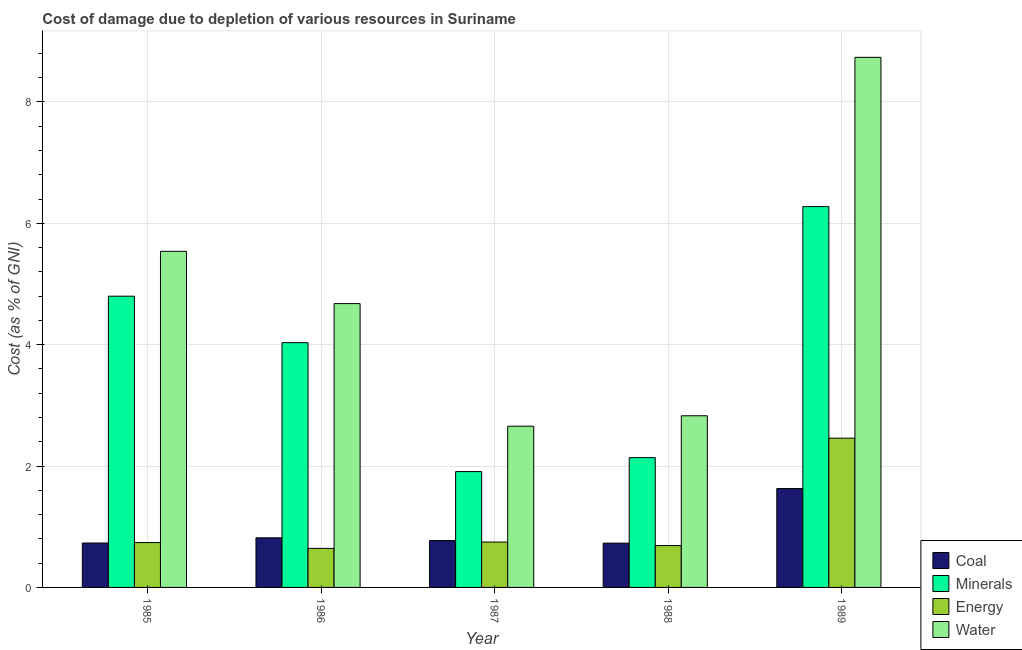How many different coloured bars are there?
Give a very brief answer. 4. What is the cost of damage due to depletion of coal in 1987?
Your response must be concise. 0.77. Across all years, what is the maximum cost of damage due to depletion of minerals?
Give a very brief answer. 6.28. Across all years, what is the minimum cost of damage due to depletion of water?
Provide a short and direct response. 2.66. In which year was the cost of damage due to depletion of water minimum?
Provide a short and direct response. 1987. What is the total cost of damage due to depletion of coal in the graph?
Provide a succinct answer. 4.68. What is the difference between the cost of damage due to depletion of minerals in 1985 and that in 1986?
Offer a terse response. 0.77. What is the difference between the cost of damage due to depletion of water in 1986 and the cost of damage due to depletion of coal in 1987?
Your answer should be compact. 2.02. What is the average cost of damage due to depletion of coal per year?
Your response must be concise. 0.94. In the year 1989, what is the difference between the cost of damage due to depletion of minerals and cost of damage due to depletion of energy?
Offer a very short reply. 0. In how many years, is the cost of damage due to depletion of water greater than 1.2000000000000002 %?
Make the answer very short. 5. What is the ratio of the cost of damage due to depletion of water in 1985 to that in 1989?
Your answer should be compact. 0.63. What is the difference between the highest and the second highest cost of damage due to depletion of water?
Keep it short and to the point. 3.2. What is the difference between the highest and the lowest cost of damage due to depletion of water?
Make the answer very short. 6.08. Is it the case that in every year, the sum of the cost of damage due to depletion of water and cost of damage due to depletion of minerals is greater than the sum of cost of damage due to depletion of coal and cost of damage due to depletion of energy?
Provide a short and direct response. Yes. What does the 2nd bar from the left in 1988 represents?
Provide a short and direct response. Minerals. What does the 1st bar from the right in 1989 represents?
Provide a succinct answer. Water. Is it the case that in every year, the sum of the cost of damage due to depletion of coal and cost of damage due to depletion of minerals is greater than the cost of damage due to depletion of energy?
Provide a succinct answer. Yes. How many bars are there?
Provide a short and direct response. 20. How many years are there in the graph?
Give a very brief answer. 5. What is the difference between two consecutive major ticks on the Y-axis?
Provide a short and direct response. 2. Are the values on the major ticks of Y-axis written in scientific E-notation?
Give a very brief answer. No. Where does the legend appear in the graph?
Provide a succinct answer. Bottom right. What is the title of the graph?
Make the answer very short. Cost of damage due to depletion of various resources in Suriname . What is the label or title of the Y-axis?
Ensure brevity in your answer.  Cost (as % of GNI). What is the Cost (as % of GNI) of Coal in 1985?
Provide a short and direct response. 0.73. What is the Cost (as % of GNI) in Minerals in 1985?
Your response must be concise. 4.8. What is the Cost (as % of GNI) of Energy in 1985?
Give a very brief answer. 0.74. What is the Cost (as % of GNI) of Water in 1985?
Ensure brevity in your answer.  5.54. What is the Cost (as % of GNI) of Coal in 1986?
Your response must be concise. 0.82. What is the Cost (as % of GNI) in Minerals in 1986?
Your response must be concise. 4.03. What is the Cost (as % of GNI) of Energy in 1986?
Your response must be concise. 0.64. What is the Cost (as % of GNI) of Water in 1986?
Provide a short and direct response. 4.68. What is the Cost (as % of GNI) in Coal in 1987?
Your response must be concise. 0.77. What is the Cost (as % of GNI) in Minerals in 1987?
Ensure brevity in your answer.  1.91. What is the Cost (as % of GNI) in Energy in 1987?
Your answer should be compact. 0.75. What is the Cost (as % of GNI) in Water in 1987?
Give a very brief answer. 2.66. What is the Cost (as % of GNI) of Coal in 1988?
Provide a short and direct response. 0.73. What is the Cost (as % of GNI) in Minerals in 1988?
Provide a short and direct response. 2.14. What is the Cost (as % of GNI) in Energy in 1988?
Give a very brief answer. 0.69. What is the Cost (as % of GNI) of Water in 1988?
Provide a succinct answer. 2.83. What is the Cost (as % of GNI) in Coal in 1989?
Keep it short and to the point. 1.63. What is the Cost (as % of GNI) in Minerals in 1989?
Provide a succinct answer. 6.28. What is the Cost (as % of GNI) of Energy in 1989?
Provide a short and direct response. 2.46. What is the Cost (as % of GNI) of Water in 1989?
Make the answer very short. 8.74. Across all years, what is the maximum Cost (as % of GNI) of Coal?
Offer a terse response. 1.63. Across all years, what is the maximum Cost (as % of GNI) of Minerals?
Provide a succinct answer. 6.28. Across all years, what is the maximum Cost (as % of GNI) of Energy?
Offer a very short reply. 2.46. Across all years, what is the maximum Cost (as % of GNI) of Water?
Your response must be concise. 8.74. Across all years, what is the minimum Cost (as % of GNI) in Coal?
Offer a terse response. 0.73. Across all years, what is the minimum Cost (as % of GNI) in Minerals?
Provide a succinct answer. 1.91. Across all years, what is the minimum Cost (as % of GNI) in Energy?
Your answer should be very brief. 0.64. Across all years, what is the minimum Cost (as % of GNI) of Water?
Offer a very short reply. 2.66. What is the total Cost (as % of GNI) of Coal in the graph?
Provide a short and direct response. 4.68. What is the total Cost (as % of GNI) of Minerals in the graph?
Offer a terse response. 19.16. What is the total Cost (as % of GNI) in Energy in the graph?
Your answer should be very brief. 5.28. What is the total Cost (as % of GNI) in Water in the graph?
Offer a terse response. 24.44. What is the difference between the Cost (as % of GNI) of Coal in 1985 and that in 1986?
Your response must be concise. -0.09. What is the difference between the Cost (as % of GNI) in Minerals in 1985 and that in 1986?
Your answer should be very brief. 0.77. What is the difference between the Cost (as % of GNI) in Energy in 1985 and that in 1986?
Ensure brevity in your answer.  0.1. What is the difference between the Cost (as % of GNI) of Water in 1985 and that in 1986?
Your response must be concise. 0.86. What is the difference between the Cost (as % of GNI) of Coal in 1985 and that in 1987?
Your response must be concise. -0.04. What is the difference between the Cost (as % of GNI) in Minerals in 1985 and that in 1987?
Keep it short and to the point. 2.89. What is the difference between the Cost (as % of GNI) in Energy in 1985 and that in 1987?
Provide a short and direct response. -0.01. What is the difference between the Cost (as % of GNI) of Water in 1985 and that in 1987?
Provide a short and direct response. 2.88. What is the difference between the Cost (as % of GNI) in Coal in 1985 and that in 1988?
Your answer should be compact. 0. What is the difference between the Cost (as % of GNI) in Minerals in 1985 and that in 1988?
Your answer should be very brief. 2.66. What is the difference between the Cost (as % of GNI) in Energy in 1985 and that in 1988?
Provide a short and direct response. 0.05. What is the difference between the Cost (as % of GNI) in Water in 1985 and that in 1988?
Provide a succinct answer. 2.71. What is the difference between the Cost (as % of GNI) of Coal in 1985 and that in 1989?
Offer a terse response. -0.9. What is the difference between the Cost (as % of GNI) in Minerals in 1985 and that in 1989?
Provide a succinct answer. -1.48. What is the difference between the Cost (as % of GNI) of Energy in 1985 and that in 1989?
Provide a succinct answer. -1.72. What is the difference between the Cost (as % of GNI) of Water in 1985 and that in 1989?
Keep it short and to the point. -3.2. What is the difference between the Cost (as % of GNI) of Coal in 1986 and that in 1987?
Your answer should be compact. 0.05. What is the difference between the Cost (as % of GNI) in Minerals in 1986 and that in 1987?
Provide a short and direct response. 2.12. What is the difference between the Cost (as % of GNI) in Energy in 1986 and that in 1987?
Your response must be concise. -0.1. What is the difference between the Cost (as % of GNI) of Water in 1986 and that in 1987?
Provide a short and direct response. 2.02. What is the difference between the Cost (as % of GNI) of Coal in 1986 and that in 1988?
Your response must be concise. 0.09. What is the difference between the Cost (as % of GNI) of Minerals in 1986 and that in 1988?
Your response must be concise. 1.89. What is the difference between the Cost (as % of GNI) of Energy in 1986 and that in 1988?
Provide a succinct answer. -0.05. What is the difference between the Cost (as % of GNI) in Water in 1986 and that in 1988?
Your response must be concise. 1.85. What is the difference between the Cost (as % of GNI) of Coal in 1986 and that in 1989?
Your response must be concise. -0.81. What is the difference between the Cost (as % of GNI) of Minerals in 1986 and that in 1989?
Offer a very short reply. -2.24. What is the difference between the Cost (as % of GNI) in Energy in 1986 and that in 1989?
Provide a short and direct response. -1.82. What is the difference between the Cost (as % of GNI) in Water in 1986 and that in 1989?
Make the answer very short. -4.06. What is the difference between the Cost (as % of GNI) of Coal in 1987 and that in 1988?
Ensure brevity in your answer.  0.04. What is the difference between the Cost (as % of GNI) in Minerals in 1987 and that in 1988?
Make the answer very short. -0.23. What is the difference between the Cost (as % of GNI) of Energy in 1987 and that in 1988?
Offer a terse response. 0.06. What is the difference between the Cost (as % of GNI) in Water in 1987 and that in 1988?
Offer a very short reply. -0.17. What is the difference between the Cost (as % of GNI) in Coal in 1987 and that in 1989?
Offer a very short reply. -0.86. What is the difference between the Cost (as % of GNI) of Minerals in 1987 and that in 1989?
Make the answer very short. -4.37. What is the difference between the Cost (as % of GNI) of Energy in 1987 and that in 1989?
Keep it short and to the point. -1.71. What is the difference between the Cost (as % of GNI) of Water in 1987 and that in 1989?
Your response must be concise. -6.08. What is the difference between the Cost (as % of GNI) of Coal in 1988 and that in 1989?
Your answer should be compact. -0.9. What is the difference between the Cost (as % of GNI) of Minerals in 1988 and that in 1989?
Your answer should be very brief. -4.14. What is the difference between the Cost (as % of GNI) in Energy in 1988 and that in 1989?
Provide a succinct answer. -1.77. What is the difference between the Cost (as % of GNI) of Water in 1988 and that in 1989?
Make the answer very short. -5.91. What is the difference between the Cost (as % of GNI) in Coal in 1985 and the Cost (as % of GNI) in Minerals in 1986?
Ensure brevity in your answer.  -3.3. What is the difference between the Cost (as % of GNI) of Coal in 1985 and the Cost (as % of GNI) of Energy in 1986?
Offer a terse response. 0.09. What is the difference between the Cost (as % of GNI) in Coal in 1985 and the Cost (as % of GNI) in Water in 1986?
Keep it short and to the point. -3.95. What is the difference between the Cost (as % of GNI) of Minerals in 1985 and the Cost (as % of GNI) of Energy in 1986?
Make the answer very short. 4.16. What is the difference between the Cost (as % of GNI) of Minerals in 1985 and the Cost (as % of GNI) of Water in 1986?
Keep it short and to the point. 0.12. What is the difference between the Cost (as % of GNI) of Energy in 1985 and the Cost (as % of GNI) of Water in 1986?
Your answer should be compact. -3.94. What is the difference between the Cost (as % of GNI) of Coal in 1985 and the Cost (as % of GNI) of Minerals in 1987?
Give a very brief answer. -1.18. What is the difference between the Cost (as % of GNI) of Coal in 1985 and the Cost (as % of GNI) of Energy in 1987?
Give a very brief answer. -0.02. What is the difference between the Cost (as % of GNI) of Coal in 1985 and the Cost (as % of GNI) of Water in 1987?
Offer a terse response. -1.93. What is the difference between the Cost (as % of GNI) of Minerals in 1985 and the Cost (as % of GNI) of Energy in 1987?
Your response must be concise. 4.05. What is the difference between the Cost (as % of GNI) in Minerals in 1985 and the Cost (as % of GNI) in Water in 1987?
Ensure brevity in your answer.  2.14. What is the difference between the Cost (as % of GNI) in Energy in 1985 and the Cost (as % of GNI) in Water in 1987?
Keep it short and to the point. -1.92. What is the difference between the Cost (as % of GNI) of Coal in 1985 and the Cost (as % of GNI) of Minerals in 1988?
Ensure brevity in your answer.  -1.41. What is the difference between the Cost (as % of GNI) in Coal in 1985 and the Cost (as % of GNI) in Energy in 1988?
Offer a very short reply. 0.04. What is the difference between the Cost (as % of GNI) of Coal in 1985 and the Cost (as % of GNI) of Water in 1988?
Offer a terse response. -2.1. What is the difference between the Cost (as % of GNI) in Minerals in 1985 and the Cost (as % of GNI) in Energy in 1988?
Make the answer very short. 4.11. What is the difference between the Cost (as % of GNI) of Minerals in 1985 and the Cost (as % of GNI) of Water in 1988?
Ensure brevity in your answer.  1.97. What is the difference between the Cost (as % of GNI) in Energy in 1985 and the Cost (as % of GNI) in Water in 1988?
Provide a succinct answer. -2.09. What is the difference between the Cost (as % of GNI) in Coal in 1985 and the Cost (as % of GNI) in Minerals in 1989?
Your answer should be very brief. -5.54. What is the difference between the Cost (as % of GNI) of Coal in 1985 and the Cost (as % of GNI) of Energy in 1989?
Make the answer very short. -1.73. What is the difference between the Cost (as % of GNI) in Coal in 1985 and the Cost (as % of GNI) in Water in 1989?
Provide a succinct answer. -8. What is the difference between the Cost (as % of GNI) in Minerals in 1985 and the Cost (as % of GNI) in Energy in 1989?
Offer a very short reply. 2.34. What is the difference between the Cost (as % of GNI) in Minerals in 1985 and the Cost (as % of GNI) in Water in 1989?
Make the answer very short. -3.94. What is the difference between the Cost (as % of GNI) of Energy in 1985 and the Cost (as % of GNI) of Water in 1989?
Keep it short and to the point. -8. What is the difference between the Cost (as % of GNI) in Coal in 1986 and the Cost (as % of GNI) in Minerals in 1987?
Your answer should be very brief. -1.09. What is the difference between the Cost (as % of GNI) of Coal in 1986 and the Cost (as % of GNI) of Energy in 1987?
Ensure brevity in your answer.  0.07. What is the difference between the Cost (as % of GNI) in Coal in 1986 and the Cost (as % of GNI) in Water in 1987?
Your answer should be very brief. -1.84. What is the difference between the Cost (as % of GNI) of Minerals in 1986 and the Cost (as % of GNI) of Energy in 1987?
Provide a short and direct response. 3.29. What is the difference between the Cost (as % of GNI) of Minerals in 1986 and the Cost (as % of GNI) of Water in 1987?
Give a very brief answer. 1.38. What is the difference between the Cost (as % of GNI) of Energy in 1986 and the Cost (as % of GNI) of Water in 1987?
Give a very brief answer. -2.01. What is the difference between the Cost (as % of GNI) of Coal in 1986 and the Cost (as % of GNI) of Minerals in 1988?
Your answer should be compact. -1.32. What is the difference between the Cost (as % of GNI) of Coal in 1986 and the Cost (as % of GNI) of Energy in 1988?
Provide a short and direct response. 0.13. What is the difference between the Cost (as % of GNI) in Coal in 1986 and the Cost (as % of GNI) in Water in 1988?
Your answer should be very brief. -2.01. What is the difference between the Cost (as % of GNI) in Minerals in 1986 and the Cost (as % of GNI) in Energy in 1988?
Your response must be concise. 3.34. What is the difference between the Cost (as % of GNI) of Minerals in 1986 and the Cost (as % of GNI) of Water in 1988?
Provide a succinct answer. 1.2. What is the difference between the Cost (as % of GNI) of Energy in 1986 and the Cost (as % of GNI) of Water in 1988?
Your answer should be compact. -2.19. What is the difference between the Cost (as % of GNI) in Coal in 1986 and the Cost (as % of GNI) in Minerals in 1989?
Make the answer very short. -5.46. What is the difference between the Cost (as % of GNI) in Coal in 1986 and the Cost (as % of GNI) in Energy in 1989?
Your answer should be very brief. -1.64. What is the difference between the Cost (as % of GNI) of Coal in 1986 and the Cost (as % of GNI) of Water in 1989?
Give a very brief answer. -7.92. What is the difference between the Cost (as % of GNI) in Minerals in 1986 and the Cost (as % of GNI) in Energy in 1989?
Provide a short and direct response. 1.57. What is the difference between the Cost (as % of GNI) in Minerals in 1986 and the Cost (as % of GNI) in Water in 1989?
Your answer should be very brief. -4.7. What is the difference between the Cost (as % of GNI) of Energy in 1986 and the Cost (as % of GNI) of Water in 1989?
Your answer should be compact. -8.09. What is the difference between the Cost (as % of GNI) in Coal in 1987 and the Cost (as % of GNI) in Minerals in 1988?
Give a very brief answer. -1.37. What is the difference between the Cost (as % of GNI) in Coal in 1987 and the Cost (as % of GNI) in Energy in 1988?
Keep it short and to the point. 0.08. What is the difference between the Cost (as % of GNI) of Coal in 1987 and the Cost (as % of GNI) of Water in 1988?
Provide a succinct answer. -2.06. What is the difference between the Cost (as % of GNI) in Minerals in 1987 and the Cost (as % of GNI) in Energy in 1988?
Provide a short and direct response. 1.22. What is the difference between the Cost (as % of GNI) of Minerals in 1987 and the Cost (as % of GNI) of Water in 1988?
Give a very brief answer. -0.92. What is the difference between the Cost (as % of GNI) of Energy in 1987 and the Cost (as % of GNI) of Water in 1988?
Keep it short and to the point. -2.08. What is the difference between the Cost (as % of GNI) in Coal in 1987 and the Cost (as % of GNI) in Minerals in 1989?
Offer a terse response. -5.5. What is the difference between the Cost (as % of GNI) in Coal in 1987 and the Cost (as % of GNI) in Energy in 1989?
Keep it short and to the point. -1.69. What is the difference between the Cost (as % of GNI) of Coal in 1987 and the Cost (as % of GNI) of Water in 1989?
Keep it short and to the point. -7.96. What is the difference between the Cost (as % of GNI) in Minerals in 1987 and the Cost (as % of GNI) in Energy in 1989?
Offer a very short reply. -0.55. What is the difference between the Cost (as % of GNI) in Minerals in 1987 and the Cost (as % of GNI) in Water in 1989?
Give a very brief answer. -6.83. What is the difference between the Cost (as % of GNI) of Energy in 1987 and the Cost (as % of GNI) of Water in 1989?
Provide a succinct answer. -7.99. What is the difference between the Cost (as % of GNI) of Coal in 1988 and the Cost (as % of GNI) of Minerals in 1989?
Your answer should be very brief. -5.55. What is the difference between the Cost (as % of GNI) of Coal in 1988 and the Cost (as % of GNI) of Energy in 1989?
Your answer should be compact. -1.73. What is the difference between the Cost (as % of GNI) in Coal in 1988 and the Cost (as % of GNI) in Water in 1989?
Your response must be concise. -8.01. What is the difference between the Cost (as % of GNI) of Minerals in 1988 and the Cost (as % of GNI) of Energy in 1989?
Offer a very short reply. -0.32. What is the difference between the Cost (as % of GNI) in Minerals in 1988 and the Cost (as % of GNI) in Water in 1989?
Your response must be concise. -6.6. What is the difference between the Cost (as % of GNI) in Energy in 1988 and the Cost (as % of GNI) in Water in 1989?
Your answer should be compact. -8.05. What is the average Cost (as % of GNI) in Coal per year?
Give a very brief answer. 0.94. What is the average Cost (as % of GNI) in Minerals per year?
Keep it short and to the point. 3.83. What is the average Cost (as % of GNI) in Energy per year?
Keep it short and to the point. 1.06. What is the average Cost (as % of GNI) in Water per year?
Your answer should be compact. 4.89. In the year 1985, what is the difference between the Cost (as % of GNI) in Coal and Cost (as % of GNI) in Minerals?
Offer a terse response. -4.07. In the year 1985, what is the difference between the Cost (as % of GNI) of Coal and Cost (as % of GNI) of Energy?
Offer a very short reply. -0.01. In the year 1985, what is the difference between the Cost (as % of GNI) in Coal and Cost (as % of GNI) in Water?
Offer a very short reply. -4.81. In the year 1985, what is the difference between the Cost (as % of GNI) of Minerals and Cost (as % of GNI) of Energy?
Your answer should be very brief. 4.06. In the year 1985, what is the difference between the Cost (as % of GNI) of Minerals and Cost (as % of GNI) of Water?
Offer a very short reply. -0.74. In the year 1985, what is the difference between the Cost (as % of GNI) in Energy and Cost (as % of GNI) in Water?
Offer a very short reply. -4.8. In the year 1986, what is the difference between the Cost (as % of GNI) in Coal and Cost (as % of GNI) in Minerals?
Give a very brief answer. -3.22. In the year 1986, what is the difference between the Cost (as % of GNI) of Coal and Cost (as % of GNI) of Energy?
Offer a terse response. 0.17. In the year 1986, what is the difference between the Cost (as % of GNI) of Coal and Cost (as % of GNI) of Water?
Provide a short and direct response. -3.86. In the year 1986, what is the difference between the Cost (as % of GNI) in Minerals and Cost (as % of GNI) in Energy?
Offer a very short reply. 3.39. In the year 1986, what is the difference between the Cost (as % of GNI) in Minerals and Cost (as % of GNI) in Water?
Give a very brief answer. -0.64. In the year 1986, what is the difference between the Cost (as % of GNI) in Energy and Cost (as % of GNI) in Water?
Offer a terse response. -4.03. In the year 1987, what is the difference between the Cost (as % of GNI) of Coal and Cost (as % of GNI) of Minerals?
Offer a very short reply. -1.14. In the year 1987, what is the difference between the Cost (as % of GNI) in Coal and Cost (as % of GNI) in Energy?
Your answer should be compact. 0.02. In the year 1987, what is the difference between the Cost (as % of GNI) of Coal and Cost (as % of GNI) of Water?
Make the answer very short. -1.88. In the year 1987, what is the difference between the Cost (as % of GNI) of Minerals and Cost (as % of GNI) of Energy?
Provide a short and direct response. 1.16. In the year 1987, what is the difference between the Cost (as % of GNI) in Minerals and Cost (as % of GNI) in Water?
Keep it short and to the point. -0.75. In the year 1987, what is the difference between the Cost (as % of GNI) in Energy and Cost (as % of GNI) in Water?
Offer a terse response. -1.91. In the year 1988, what is the difference between the Cost (as % of GNI) in Coal and Cost (as % of GNI) in Minerals?
Make the answer very short. -1.41. In the year 1988, what is the difference between the Cost (as % of GNI) in Coal and Cost (as % of GNI) in Energy?
Make the answer very short. 0.04. In the year 1988, what is the difference between the Cost (as % of GNI) in Coal and Cost (as % of GNI) in Water?
Offer a very short reply. -2.1. In the year 1988, what is the difference between the Cost (as % of GNI) of Minerals and Cost (as % of GNI) of Energy?
Ensure brevity in your answer.  1.45. In the year 1988, what is the difference between the Cost (as % of GNI) in Minerals and Cost (as % of GNI) in Water?
Make the answer very short. -0.69. In the year 1988, what is the difference between the Cost (as % of GNI) of Energy and Cost (as % of GNI) of Water?
Give a very brief answer. -2.14. In the year 1989, what is the difference between the Cost (as % of GNI) in Coal and Cost (as % of GNI) in Minerals?
Give a very brief answer. -4.65. In the year 1989, what is the difference between the Cost (as % of GNI) in Coal and Cost (as % of GNI) in Energy?
Make the answer very short. -0.83. In the year 1989, what is the difference between the Cost (as % of GNI) in Coal and Cost (as % of GNI) in Water?
Your answer should be compact. -7.11. In the year 1989, what is the difference between the Cost (as % of GNI) of Minerals and Cost (as % of GNI) of Energy?
Your answer should be very brief. 3.82. In the year 1989, what is the difference between the Cost (as % of GNI) in Minerals and Cost (as % of GNI) in Water?
Ensure brevity in your answer.  -2.46. In the year 1989, what is the difference between the Cost (as % of GNI) of Energy and Cost (as % of GNI) of Water?
Your answer should be very brief. -6.28. What is the ratio of the Cost (as % of GNI) in Coal in 1985 to that in 1986?
Offer a very short reply. 0.9. What is the ratio of the Cost (as % of GNI) of Minerals in 1985 to that in 1986?
Keep it short and to the point. 1.19. What is the ratio of the Cost (as % of GNI) in Energy in 1985 to that in 1986?
Keep it short and to the point. 1.15. What is the ratio of the Cost (as % of GNI) in Water in 1985 to that in 1986?
Your answer should be very brief. 1.18. What is the ratio of the Cost (as % of GNI) in Coal in 1985 to that in 1987?
Offer a very short reply. 0.95. What is the ratio of the Cost (as % of GNI) in Minerals in 1985 to that in 1987?
Make the answer very short. 2.51. What is the ratio of the Cost (as % of GNI) of Energy in 1985 to that in 1987?
Your answer should be very brief. 0.99. What is the ratio of the Cost (as % of GNI) of Water in 1985 to that in 1987?
Your response must be concise. 2.08. What is the ratio of the Cost (as % of GNI) of Coal in 1985 to that in 1988?
Give a very brief answer. 1. What is the ratio of the Cost (as % of GNI) of Minerals in 1985 to that in 1988?
Your response must be concise. 2.24. What is the ratio of the Cost (as % of GNI) in Energy in 1985 to that in 1988?
Offer a terse response. 1.07. What is the ratio of the Cost (as % of GNI) in Water in 1985 to that in 1988?
Keep it short and to the point. 1.96. What is the ratio of the Cost (as % of GNI) in Coal in 1985 to that in 1989?
Offer a very short reply. 0.45. What is the ratio of the Cost (as % of GNI) in Minerals in 1985 to that in 1989?
Offer a terse response. 0.76. What is the ratio of the Cost (as % of GNI) in Energy in 1985 to that in 1989?
Offer a terse response. 0.3. What is the ratio of the Cost (as % of GNI) of Water in 1985 to that in 1989?
Provide a succinct answer. 0.63. What is the ratio of the Cost (as % of GNI) of Coal in 1986 to that in 1987?
Your answer should be compact. 1.06. What is the ratio of the Cost (as % of GNI) of Minerals in 1986 to that in 1987?
Your answer should be very brief. 2.11. What is the ratio of the Cost (as % of GNI) in Energy in 1986 to that in 1987?
Give a very brief answer. 0.86. What is the ratio of the Cost (as % of GNI) of Water in 1986 to that in 1987?
Provide a short and direct response. 1.76. What is the ratio of the Cost (as % of GNI) in Coal in 1986 to that in 1988?
Your answer should be very brief. 1.12. What is the ratio of the Cost (as % of GNI) in Minerals in 1986 to that in 1988?
Your response must be concise. 1.89. What is the ratio of the Cost (as % of GNI) of Energy in 1986 to that in 1988?
Give a very brief answer. 0.93. What is the ratio of the Cost (as % of GNI) in Water in 1986 to that in 1988?
Keep it short and to the point. 1.65. What is the ratio of the Cost (as % of GNI) of Coal in 1986 to that in 1989?
Make the answer very short. 0.5. What is the ratio of the Cost (as % of GNI) of Minerals in 1986 to that in 1989?
Offer a terse response. 0.64. What is the ratio of the Cost (as % of GNI) in Energy in 1986 to that in 1989?
Offer a terse response. 0.26. What is the ratio of the Cost (as % of GNI) in Water in 1986 to that in 1989?
Give a very brief answer. 0.54. What is the ratio of the Cost (as % of GNI) in Coal in 1987 to that in 1988?
Your answer should be compact. 1.06. What is the ratio of the Cost (as % of GNI) in Minerals in 1987 to that in 1988?
Your answer should be compact. 0.89. What is the ratio of the Cost (as % of GNI) in Energy in 1987 to that in 1988?
Keep it short and to the point. 1.08. What is the ratio of the Cost (as % of GNI) of Water in 1987 to that in 1988?
Offer a very short reply. 0.94. What is the ratio of the Cost (as % of GNI) in Coal in 1987 to that in 1989?
Make the answer very short. 0.47. What is the ratio of the Cost (as % of GNI) in Minerals in 1987 to that in 1989?
Keep it short and to the point. 0.3. What is the ratio of the Cost (as % of GNI) in Energy in 1987 to that in 1989?
Offer a terse response. 0.3. What is the ratio of the Cost (as % of GNI) of Water in 1987 to that in 1989?
Offer a terse response. 0.3. What is the ratio of the Cost (as % of GNI) of Coal in 1988 to that in 1989?
Provide a succinct answer. 0.45. What is the ratio of the Cost (as % of GNI) in Minerals in 1988 to that in 1989?
Your response must be concise. 0.34. What is the ratio of the Cost (as % of GNI) in Energy in 1988 to that in 1989?
Your answer should be very brief. 0.28. What is the ratio of the Cost (as % of GNI) of Water in 1988 to that in 1989?
Your response must be concise. 0.32. What is the difference between the highest and the second highest Cost (as % of GNI) of Coal?
Give a very brief answer. 0.81. What is the difference between the highest and the second highest Cost (as % of GNI) in Minerals?
Your response must be concise. 1.48. What is the difference between the highest and the second highest Cost (as % of GNI) in Energy?
Keep it short and to the point. 1.71. What is the difference between the highest and the second highest Cost (as % of GNI) in Water?
Offer a very short reply. 3.2. What is the difference between the highest and the lowest Cost (as % of GNI) of Coal?
Your response must be concise. 0.9. What is the difference between the highest and the lowest Cost (as % of GNI) in Minerals?
Provide a short and direct response. 4.37. What is the difference between the highest and the lowest Cost (as % of GNI) of Energy?
Keep it short and to the point. 1.82. What is the difference between the highest and the lowest Cost (as % of GNI) of Water?
Offer a very short reply. 6.08. 